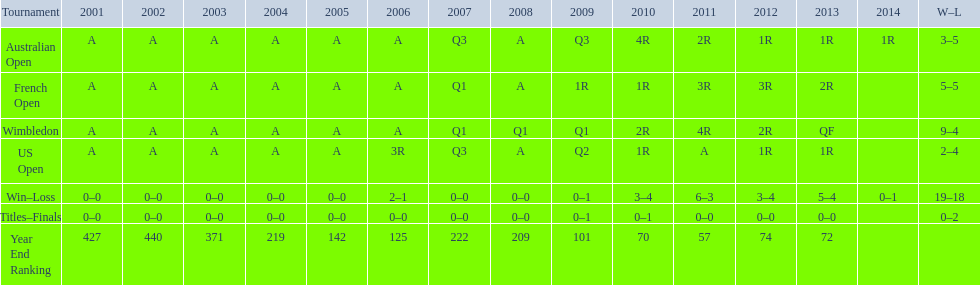In what year was the best year end ranking achieved? 2011. 